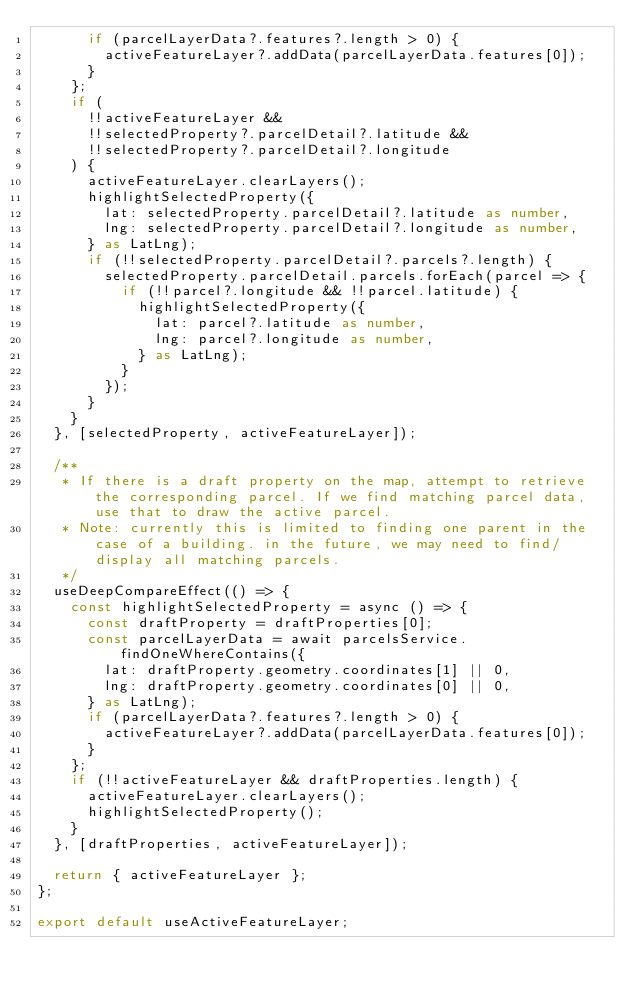<code> <loc_0><loc_0><loc_500><loc_500><_TypeScript_>      if (parcelLayerData?.features?.length > 0) {
        activeFeatureLayer?.addData(parcelLayerData.features[0]);
      }
    };
    if (
      !!activeFeatureLayer &&
      !!selectedProperty?.parcelDetail?.latitude &&
      !!selectedProperty?.parcelDetail?.longitude
    ) {
      activeFeatureLayer.clearLayers();
      highlightSelectedProperty({
        lat: selectedProperty.parcelDetail?.latitude as number,
        lng: selectedProperty.parcelDetail?.longitude as number,
      } as LatLng);
      if (!!selectedProperty.parcelDetail?.parcels?.length) {
        selectedProperty.parcelDetail.parcels.forEach(parcel => {
          if (!!parcel?.longitude && !!parcel.latitude) {
            highlightSelectedProperty({
              lat: parcel?.latitude as number,
              lng: parcel?.longitude as number,
            } as LatLng);
          }
        });
      }
    }
  }, [selectedProperty, activeFeatureLayer]);

  /**
   * If there is a draft property on the map, attempt to retrieve the corresponding parcel. If we find matching parcel data, use that to draw the active parcel.
   * Note: currently this is limited to finding one parent in the case of a building. in the future, we may need to find/display all matching parcels.
   */
  useDeepCompareEffect(() => {
    const highlightSelectedProperty = async () => {
      const draftProperty = draftProperties[0];
      const parcelLayerData = await parcelsService.findOneWhereContains({
        lat: draftProperty.geometry.coordinates[1] || 0,
        lng: draftProperty.geometry.coordinates[0] || 0,
      } as LatLng);
      if (parcelLayerData?.features?.length > 0) {
        activeFeatureLayer?.addData(parcelLayerData.features[0]);
      }
    };
    if (!!activeFeatureLayer && draftProperties.length) {
      activeFeatureLayer.clearLayers();
      highlightSelectedProperty();
    }
  }, [draftProperties, activeFeatureLayer]);

  return { activeFeatureLayer };
};

export default useActiveFeatureLayer;
</code> 